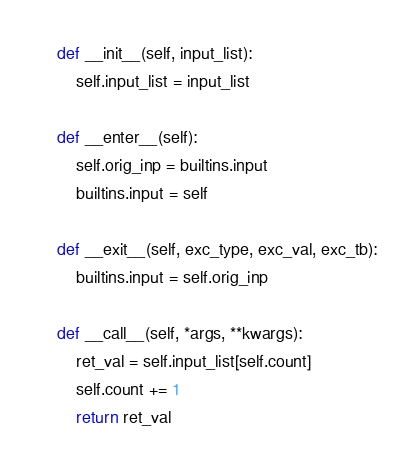<code> <loc_0><loc_0><loc_500><loc_500><_Python_>
    def __init__(self, input_list):
        self.input_list = input_list

    def __enter__(self):
        self.orig_inp = builtins.input
        builtins.input = self

    def __exit__(self, exc_type, exc_val, exc_tb):
        builtins.input = self.orig_inp

    def __call__(self, *args, **kwargs):
        ret_val = self.input_list[self.count]
        self.count += 1
        return ret_val
</code> 